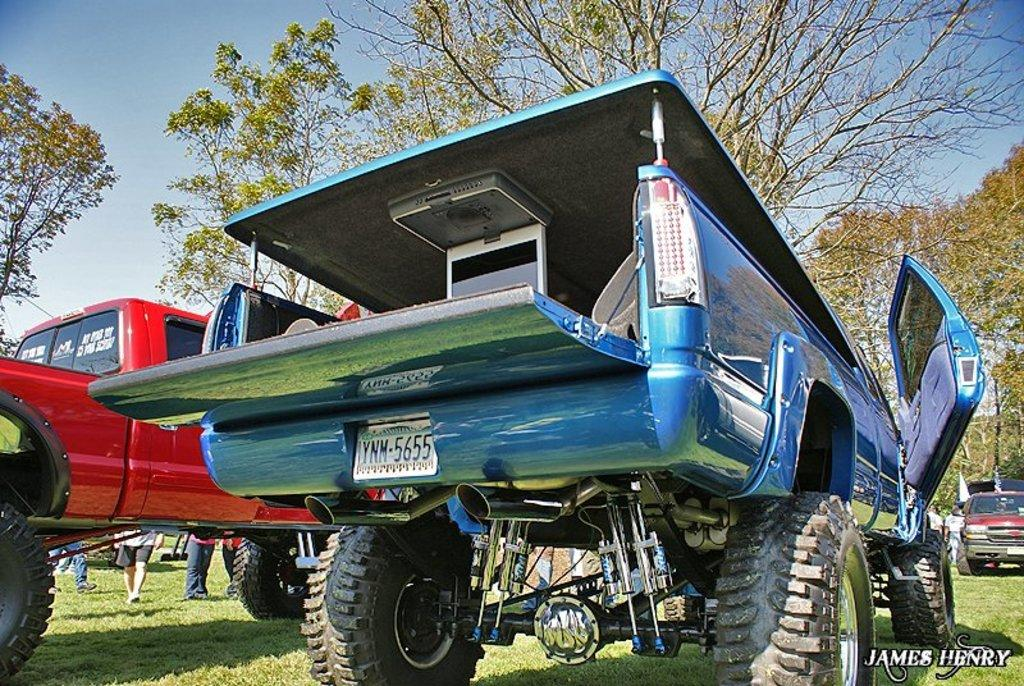What is the main subject of the image? The main subject of the image is a truck. Are there any people present in the image? Yes, there are people standing near the truck. What type of natural environment can be seen in the image? There is grass and trees visible in the image. What is visible at the top of the image? The sky is visible at the top of the image. What type of brush is being used to clean the truck in the image? There is no brush visible in the image, and no cleaning activity is taking place. 